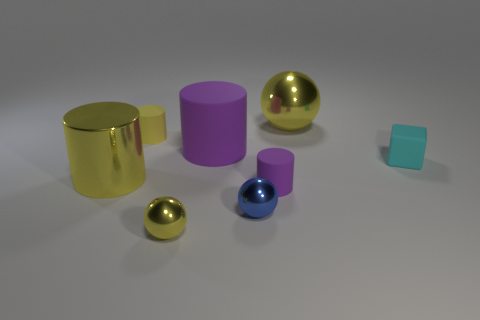Is there anything else that has the same size as the metal cylinder?
Offer a very short reply. Yes. What is the size of the yellow shiny sphere that is in front of the small object right of the tiny cylinder that is in front of the block?
Ensure brevity in your answer.  Small. Are there any matte things that have the same color as the big matte cylinder?
Give a very brief answer. Yes. What number of large cyan cylinders are there?
Make the answer very short. 0. What is the tiny ball that is in front of the tiny metal ball behind the metal object in front of the blue metal sphere made of?
Give a very brief answer. Metal. Is there a big purple object that has the same material as the small cyan block?
Your answer should be compact. Yes. Does the small cyan thing have the same material as the small blue sphere?
Your response must be concise. No. What number of blocks are small blue shiny things or big matte objects?
Offer a terse response. 0. What color is the other tiny object that is made of the same material as the small blue object?
Your answer should be compact. Yellow. Are there fewer small green matte blocks than tiny matte objects?
Make the answer very short. Yes. 